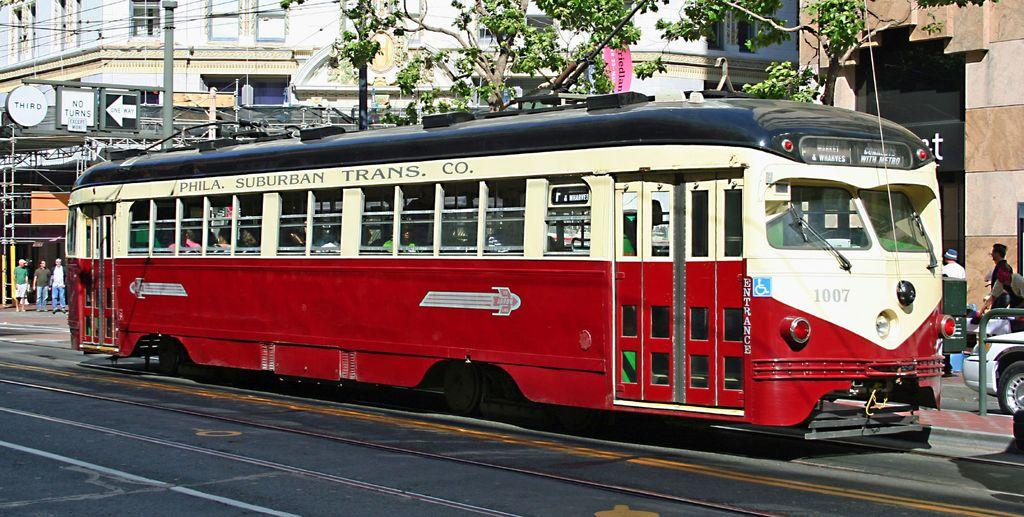What type of vehicle is in the image? There is a red color bus in the image. Who or what can be seen in the image besides the bus? There are people, cars, trees, and buildings visible in the image. What is the purpose of the current pole in the image? The current pole is likely used for providing electricity to the surrounding area. What type of plantation can be seen in the image? There is no plantation present in the image. How many beds are visible in the image? There are no beds visible in the image. 